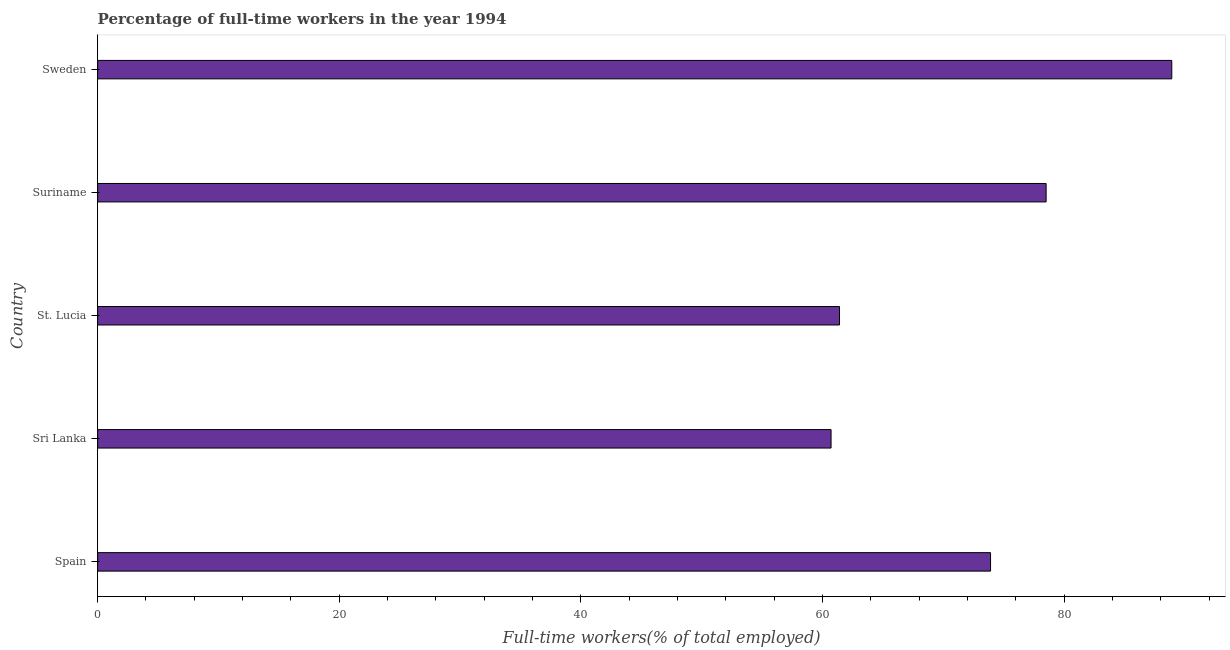Does the graph contain any zero values?
Provide a succinct answer. No. What is the title of the graph?
Provide a succinct answer. Percentage of full-time workers in the year 1994. What is the label or title of the X-axis?
Offer a very short reply. Full-time workers(% of total employed). What is the percentage of full-time workers in Sri Lanka?
Keep it short and to the point. 60.7. Across all countries, what is the maximum percentage of full-time workers?
Provide a short and direct response. 88.9. Across all countries, what is the minimum percentage of full-time workers?
Make the answer very short. 60.7. In which country was the percentage of full-time workers maximum?
Offer a very short reply. Sweden. In which country was the percentage of full-time workers minimum?
Offer a terse response. Sri Lanka. What is the sum of the percentage of full-time workers?
Make the answer very short. 363.4. What is the average percentage of full-time workers per country?
Your answer should be compact. 72.68. What is the median percentage of full-time workers?
Give a very brief answer. 73.9. In how many countries, is the percentage of full-time workers greater than 56 %?
Keep it short and to the point. 5. What is the ratio of the percentage of full-time workers in Suriname to that in Sweden?
Give a very brief answer. 0.88. What is the difference between the highest and the second highest percentage of full-time workers?
Your response must be concise. 10.4. Is the sum of the percentage of full-time workers in Spain and Suriname greater than the maximum percentage of full-time workers across all countries?
Keep it short and to the point. Yes. What is the difference between the highest and the lowest percentage of full-time workers?
Ensure brevity in your answer.  28.2. How many bars are there?
Offer a very short reply. 5. Are all the bars in the graph horizontal?
Give a very brief answer. Yes. What is the Full-time workers(% of total employed) in Spain?
Ensure brevity in your answer.  73.9. What is the Full-time workers(% of total employed) in Sri Lanka?
Keep it short and to the point. 60.7. What is the Full-time workers(% of total employed) of St. Lucia?
Make the answer very short. 61.4. What is the Full-time workers(% of total employed) of Suriname?
Your answer should be very brief. 78.5. What is the Full-time workers(% of total employed) in Sweden?
Provide a succinct answer. 88.9. What is the difference between the Full-time workers(% of total employed) in Spain and St. Lucia?
Make the answer very short. 12.5. What is the difference between the Full-time workers(% of total employed) in Sri Lanka and Suriname?
Give a very brief answer. -17.8. What is the difference between the Full-time workers(% of total employed) in Sri Lanka and Sweden?
Offer a terse response. -28.2. What is the difference between the Full-time workers(% of total employed) in St. Lucia and Suriname?
Offer a terse response. -17.1. What is the difference between the Full-time workers(% of total employed) in St. Lucia and Sweden?
Your response must be concise. -27.5. What is the difference between the Full-time workers(% of total employed) in Suriname and Sweden?
Your response must be concise. -10.4. What is the ratio of the Full-time workers(% of total employed) in Spain to that in Sri Lanka?
Offer a very short reply. 1.22. What is the ratio of the Full-time workers(% of total employed) in Spain to that in St. Lucia?
Your answer should be compact. 1.2. What is the ratio of the Full-time workers(% of total employed) in Spain to that in Suriname?
Make the answer very short. 0.94. What is the ratio of the Full-time workers(% of total employed) in Spain to that in Sweden?
Your answer should be very brief. 0.83. What is the ratio of the Full-time workers(% of total employed) in Sri Lanka to that in St. Lucia?
Provide a succinct answer. 0.99. What is the ratio of the Full-time workers(% of total employed) in Sri Lanka to that in Suriname?
Offer a terse response. 0.77. What is the ratio of the Full-time workers(% of total employed) in Sri Lanka to that in Sweden?
Your response must be concise. 0.68. What is the ratio of the Full-time workers(% of total employed) in St. Lucia to that in Suriname?
Give a very brief answer. 0.78. What is the ratio of the Full-time workers(% of total employed) in St. Lucia to that in Sweden?
Make the answer very short. 0.69. What is the ratio of the Full-time workers(% of total employed) in Suriname to that in Sweden?
Offer a very short reply. 0.88. 